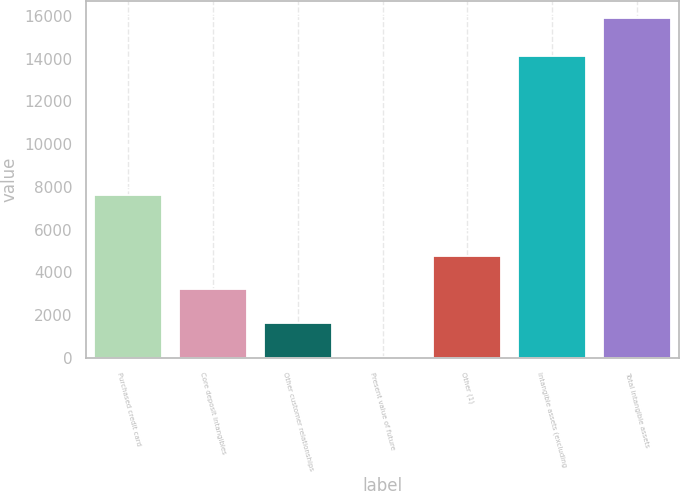<chart> <loc_0><loc_0><loc_500><loc_500><bar_chart><fcel>Purchased credit card<fcel>Core deposit intangibles<fcel>Other customer relationships<fcel>Present value of future<fcel>Other (1)<fcel>Intangible assets (excluding<fcel>Total intangible assets<nl><fcel>7606<fcel>3207.2<fcel>1622.1<fcel>37<fcel>4792.3<fcel>14107<fcel>15888<nl></chart> 